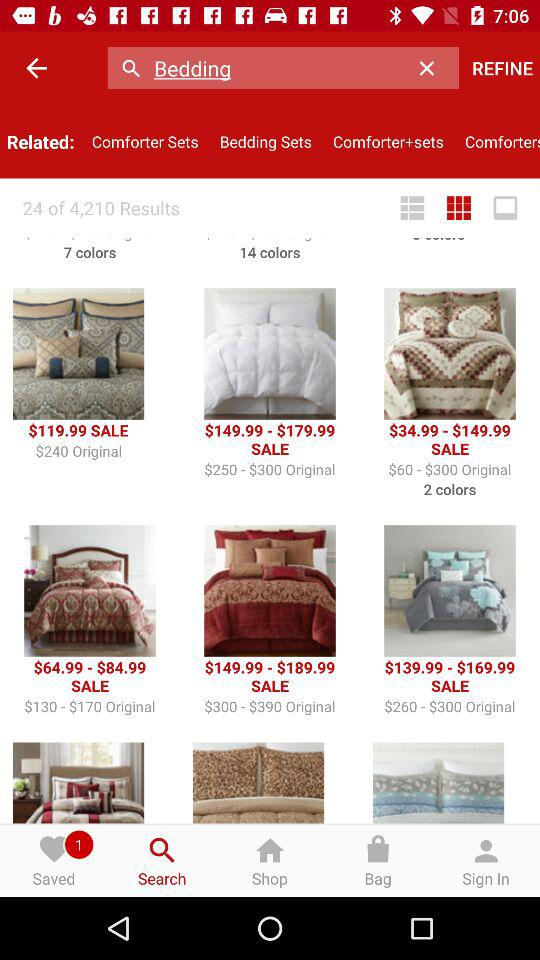What is the currency of price? The currency of price is dollars. 